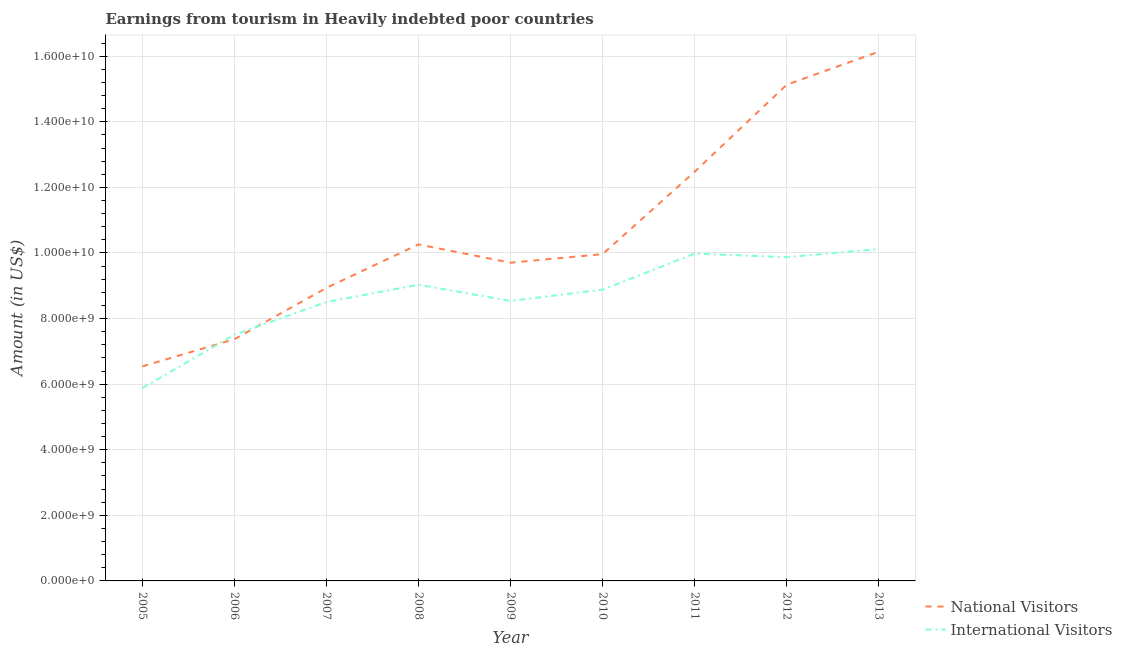Does the line corresponding to amount earned from international visitors intersect with the line corresponding to amount earned from national visitors?
Provide a succinct answer. Yes. What is the amount earned from international visitors in 2008?
Give a very brief answer. 9.03e+09. Across all years, what is the maximum amount earned from national visitors?
Your response must be concise. 1.61e+1. Across all years, what is the minimum amount earned from national visitors?
Keep it short and to the point. 6.54e+09. In which year was the amount earned from national visitors maximum?
Provide a succinct answer. 2013. In which year was the amount earned from national visitors minimum?
Provide a succinct answer. 2005. What is the total amount earned from national visitors in the graph?
Give a very brief answer. 9.65e+1. What is the difference between the amount earned from national visitors in 2007 and that in 2008?
Give a very brief answer. -1.33e+09. What is the difference between the amount earned from international visitors in 2012 and the amount earned from national visitors in 2007?
Keep it short and to the point. 9.35e+08. What is the average amount earned from national visitors per year?
Your answer should be compact. 1.07e+1. In the year 2007, what is the difference between the amount earned from international visitors and amount earned from national visitors?
Your answer should be very brief. -4.31e+08. What is the ratio of the amount earned from national visitors in 2005 to that in 2011?
Make the answer very short. 0.52. What is the difference between the highest and the second highest amount earned from national visitors?
Give a very brief answer. 1.01e+09. What is the difference between the highest and the lowest amount earned from national visitors?
Make the answer very short. 9.60e+09. Is the sum of the amount earned from national visitors in 2012 and 2013 greater than the maximum amount earned from international visitors across all years?
Make the answer very short. Yes. Is the amount earned from international visitors strictly less than the amount earned from national visitors over the years?
Your response must be concise. No. How many lines are there?
Provide a short and direct response. 2. Does the graph contain any zero values?
Offer a very short reply. No. Does the graph contain grids?
Offer a very short reply. Yes. Where does the legend appear in the graph?
Provide a short and direct response. Bottom right. What is the title of the graph?
Keep it short and to the point. Earnings from tourism in Heavily indebted poor countries. What is the label or title of the X-axis?
Keep it short and to the point. Year. What is the Amount (in US$) in National Visitors in 2005?
Give a very brief answer. 6.54e+09. What is the Amount (in US$) of International Visitors in 2005?
Offer a terse response. 5.88e+09. What is the Amount (in US$) in National Visitors in 2006?
Offer a terse response. 7.37e+09. What is the Amount (in US$) in International Visitors in 2006?
Your response must be concise. 7.51e+09. What is the Amount (in US$) of National Visitors in 2007?
Offer a very short reply. 8.94e+09. What is the Amount (in US$) of International Visitors in 2007?
Your response must be concise. 8.50e+09. What is the Amount (in US$) in National Visitors in 2008?
Provide a succinct answer. 1.03e+1. What is the Amount (in US$) of International Visitors in 2008?
Offer a very short reply. 9.03e+09. What is the Amount (in US$) of National Visitors in 2009?
Offer a terse response. 9.70e+09. What is the Amount (in US$) of International Visitors in 2009?
Ensure brevity in your answer.  8.54e+09. What is the Amount (in US$) in National Visitors in 2010?
Your answer should be very brief. 9.96e+09. What is the Amount (in US$) of International Visitors in 2010?
Your answer should be very brief. 8.88e+09. What is the Amount (in US$) in National Visitors in 2011?
Offer a very short reply. 1.25e+1. What is the Amount (in US$) of International Visitors in 2011?
Provide a succinct answer. 9.98e+09. What is the Amount (in US$) of National Visitors in 2012?
Give a very brief answer. 1.51e+1. What is the Amount (in US$) of International Visitors in 2012?
Ensure brevity in your answer.  9.87e+09. What is the Amount (in US$) of National Visitors in 2013?
Your response must be concise. 1.61e+1. What is the Amount (in US$) of International Visitors in 2013?
Your answer should be compact. 1.01e+1. Across all years, what is the maximum Amount (in US$) in National Visitors?
Your answer should be compact. 1.61e+1. Across all years, what is the maximum Amount (in US$) in International Visitors?
Give a very brief answer. 1.01e+1. Across all years, what is the minimum Amount (in US$) in National Visitors?
Offer a very short reply. 6.54e+09. Across all years, what is the minimum Amount (in US$) of International Visitors?
Give a very brief answer. 5.88e+09. What is the total Amount (in US$) of National Visitors in the graph?
Provide a short and direct response. 9.65e+1. What is the total Amount (in US$) in International Visitors in the graph?
Provide a short and direct response. 7.83e+1. What is the difference between the Amount (in US$) of National Visitors in 2005 and that in 2006?
Your answer should be compact. -8.28e+08. What is the difference between the Amount (in US$) of International Visitors in 2005 and that in 2006?
Provide a succinct answer. -1.63e+09. What is the difference between the Amount (in US$) of National Visitors in 2005 and that in 2007?
Provide a short and direct response. -2.39e+09. What is the difference between the Amount (in US$) of International Visitors in 2005 and that in 2007?
Ensure brevity in your answer.  -2.62e+09. What is the difference between the Amount (in US$) of National Visitors in 2005 and that in 2008?
Ensure brevity in your answer.  -3.72e+09. What is the difference between the Amount (in US$) of International Visitors in 2005 and that in 2008?
Your answer should be compact. -3.15e+09. What is the difference between the Amount (in US$) of National Visitors in 2005 and that in 2009?
Give a very brief answer. -3.16e+09. What is the difference between the Amount (in US$) in International Visitors in 2005 and that in 2009?
Make the answer very short. -2.66e+09. What is the difference between the Amount (in US$) of National Visitors in 2005 and that in 2010?
Make the answer very short. -3.42e+09. What is the difference between the Amount (in US$) in International Visitors in 2005 and that in 2010?
Your response must be concise. -3.00e+09. What is the difference between the Amount (in US$) of National Visitors in 2005 and that in 2011?
Provide a succinct answer. -5.93e+09. What is the difference between the Amount (in US$) in International Visitors in 2005 and that in 2011?
Your response must be concise. -4.10e+09. What is the difference between the Amount (in US$) of National Visitors in 2005 and that in 2012?
Offer a terse response. -8.59e+09. What is the difference between the Amount (in US$) of International Visitors in 2005 and that in 2012?
Provide a short and direct response. -3.99e+09. What is the difference between the Amount (in US$) in National Visitors in 2005 and that in 2013?
Offer a very short reply. -9.60e+09. What is the difference between the Amount (in US$) of International Visitors in 2005 and that in 2013?
Your answer should be compact. -4.24e+09. What is the difference between the Amount (in US$) in National Visitors in 2006 and that in 2007?
Offer a very short reply. -1.57e+09. What is the difference between the Amount (in US$) of International Visitors in 2006 and that in 2007?
Your answer should be very brief. -9.96e+08. What is the difference between the Amount (in US$) in National Visitors in 2006 and that in 2008?
Give a very brief answer. -2.89e+09. What is the difference between the Amount (in US$) of International Visitors in 2006 and that in 2008?
Ensure brevity in your answer.  -1.52e+09. What is the difference between the Amount (in US$) in National Visitors in 2006 and that in 2009?
Make the answer very short. -2.33e+09. What is the difference between the Amount (in US$) in International Visitors in 2006 and that in 2009?
Provide a short and direct response. -1.03e+09. What is the difference between the Amount (in US$) of National Visitors in 2006 and that in 2010?
Your response must be concise. -2.59e+09. What is the difference between the Amount (in US$) in International Visitors in 2006 and that in 2010?
Make the answer very short. -1.37e+09. What is the difference between the Amount (in US$) in National Visitors in 2006 and that in 2011?
Your response must be concise. -5.11e+09. What is the difference between the Amount (in US$) of International Visitors in 2006 and that in 2011?
Offer a terse response. -2.47e+09. What is the difference between the Amount (in US$) in National Visitors in 2006 and that in 2012?
Offer a very short reply. -7.76e+09. What is the difference between the Amount (in US$) of International Visitors in 2006 and that in 2012?
Your answer should be very brief. -2.36e+09. What is the difference between the Amount (in US$) in National Visitors in 2006 and that in 2013?
Offer a terse response. -8.77e+09. What is the difference between the Amount (in US$) in International Visitors in 2006 and that in 2013?
Keep it short and to the point. -2.61e+09. What is the difference between the Amount (in US$) of National Visitors in 2007 and that in 2008?
Give a very brief answer. -1.33e+09. What is the difference between the Amount (in US$) in International Visitors in 2007 and that in 2008?
Offer a very short reply. -5.27e+08. What is the difference between the Amount (in US$) in National Visitors in 2007 and that in 2009?
Give a very brief answer. -7.68e+08. What is the difference between the Amount (in US$) in International Visitors in 2007 and that in 2009?
Your response must be concise. -3.33e+07. What is the difference between the Amount (in US$) of National Visitors in 2007 and that in 2010?
Your response must be concise. -1.03e+09. What is the difference between the Amount (in US$) of International Visitors in 2007 and that in 2010?
Provide a succinct answer. -3.77e+08. What is the difference between the Amount (in US$) of National Visitors in 2007 and that in 2011?
Provide a short and direct response. -3.54e+09. What is the difference between the Amount (in US$) in International Visitors in 2007 and that in 2011?
Give a very brief answer. -1.48e+09. What is the difference between the Amount (in US$) in National Visitors in 2007 and that in 2012?
Provide a succinct answer. -6.19e+09. What is the difference between the Amount (in US$) in International Visitors in 2007 and that in 2012?
Offer a very short reply. -1.37e+09. What is the difference between the Amount (in US$) of National Visitors in 2007 and that in 2013?
Provide a short and direct response. -7.20e+09. What is the difference between the Amount (in US$) of International Visitors in 2007 and that in 2013?
Your answer should be very brief. -1.62e+09. What is the difference between the Amount (in US$) in National Visitors in 2008 and that in 2009?
Provide a short and direct response. 5.58e+08. What is the difference between the Amount (in US$) in International Visitors in 2008 and that in 2009?
Give a very brief answer. 4.94e+08. What is the difference between the Amount (in US$) of National Visitors in 2008 and that in 2010?
Your answer should be compact. 2.97e+08. What is the difference between the Amount (in US$) of International Visitors in 2008 and that in 2010?
Your response must be concise. 1.50e+08. What is the difference between the Amount (in US$) of National Visitors in 2008 and that in 2011?
Give a very brief answer. -2.22e+09. What is the difference between the Amount (in US$) in International Visitors in 2008 and that in 2011?
Offer a very short reply. -9.49e+08. What is the difference between the Amount (in US$) in National Visitors in 2008 and that in 2012?
Provide a short and direct response. -4.87e+09. What is the difference between the Amount (in US$) in International Visitors in 2008 and that in 2012?
Your answer should be compact. -8.39e+08. What is the difference between the Amount (in US$) of National Visitors in 2008 and that in 2013?
Your response must be concise. -5.88e+09. What is the difference between the Amount (in US$) in International Visitors in 2008 and that in 2013?
Provide a short and direct response. -1.09e+09. What is the difference between the Amount (in US$) of National Visitors in 2009 and that in 2010?
Offer a terse response. -2.61e+08. What is the difference between the Amount (in US$) of International Visitors in 2009 and that in 2010?
Ensure brevity in your answer.  -3.44e+08. What is the difference between the Amount (in US$) in National Visitors in 2009 and that in 2011?
Give a very brief answer. -2.77e+09. What is the difference between the Amount (in US$) of International Visitors in 2009 and that in 2011?
Offer a very short reply. -1.44e+09. What is the difference between the Amount (in US$) of National Visitors in 2009 and that in 2012?
Offer a very short reply. -5.43e+09. What is the difference between the Amount (in US$) of International Visitors in 2009 and that in 2012?
Offer a very short reply. -1.33e+09. What is the difference between the Amount (in US$) in National Visitors in 2009 and that in 2013?
Give a very brief answer. -6.43e+09. What is the difference between the Amount (in US$) of International Visitors in 2009 and that in 2013?
Provide a short and direct response. -1.58e+09. What is the difference between the Amount (in US$) in National Visitors in 2010 and that in 2011?
Offer a very short reply. -2.51e+09. What is the difference between the Amount (in US$) in International Visitors in 2010 and that in 2011?
Your answer should be compact. -1.10e+09. What is the difference between the Amount (in US$) in National Visitors in 2010 and that in 2012?
Offer a terse response. -5.17e+09. What is the difference between the Amount (in US$) of International Visitors in 2010 and that in 2012?
Your response must be concise. -9.89e+08. What is the difference between the Amount (in US$) of National Visitors in 2010 and that in 2013?
Ensure brevity in your answer.  -6.17e+09. What is the difference between the Amount (in US$) of International Visitors in 2010 and that in 2013?
Your response must be concise. -1.24e+09. What is the difference between the Amount (in US$) in National Visitors in 2011 and that in 2012?
Provide a succinct answer. -2.65e+09. What is the difference between the Amount (in US$) in International Visitors in 2011 and that in 2012?
Make the answer very short. 1.10e+08. What is the difference between the Amount (in US$) in National Visitors in 2011 and that in 2013?
Offer a very short reply. -3.66e+09. What is the difference between the Amount (in US$) in International Visitors in 2011 and that in 2013?
Offer a terse response. -1.41e+08. What is the difference between the Amount (in US$) of National Visitors in 2012 and that in 2013?
Give a very brief answer. -1.01e+09. What is the difference between the Amount (in US$) of International Visitors in 2012 and that in 2013?
Your answer should be compact. -2.51e+08. What is the difference between the Amount (in US$) of National Visitors in 2005 and the Amount (in US$) of International Visitors in 2006?
Give a very brief answer. -9.66e+08. What is the difference between the Amount (in US$) in National Visitors in 2005 and the Amount (in US$) in International Visitors in 2007?
Your answer should be compact. -1.96e+09. What is the difference between the Amount (in US$) of National Visitors in 2005 and the Amount (in US$) of International Visitors in 2008?
Your answer should be compact. -2.49e+09. What is the difference between the Amount (in US$) of National Visitors in 2005 and the Amount (in US$) of International Visitors in 2009?
Your answer should be very brief. -2.00e+09. What is the difference between the Amount (in US$) of National Visitors in 2005 and the Amount (in US$) of International Visitors in 2010?
Offer a terse response. -2.34e+09. What is the difference between the Amount (in US$) of National Visitors in 2005 and the Amount (in US$) of International Visitors in 2011?
Keep it short and to the point. -3.44e+09. What is the difference between the Amount (in US$) in National Visitors in 2005 and the Amount (in US$) in International Visitors in 2012?
Your answer should be very brief. -3.33e+09. What is the difference between the Amount (in US$) in National Visitors in 2005 and the Amount (in US$) in International Visitors in 2013?
Offer a terse response. -3.58e+09. What is the difference between the Amount (in US$) in National Visitors in 2006 and the Amount (in US$) in International Visitors in 2007?
Your answer should be very brief. -1.13e+09. What is the difference between the Amount (in US$) in National Visitors in 2006 and the Amount (in US$) in International Visitors in 2008?
Provide a succinct answer. -1.66e+09. What is the difference between the Amount (in US$) of National Visitors in 2006 and the Amount (in US$) of International Visitors in 2009?
Make the answer very short. -1.17e+09. What is the difference between the Amount (in US$) in National Visitors in 2006 and the Amount (in US$) in International Visitors in 2010?
Your answer should be compact. -1.51e+09. What is the difference between the Amount (in US$) of National Visitors in 2006 and the Amount (in US$) of International Visitors in 2011?
Make the answer very short. -2.61e+09. What is the difference between the Amount (in US$) in National Visitors in 2006 and the Amount (in US$) in International Visitors in 2012?
Provide a succinct answer. -2.50e+09. What is the difference between the Amount (in US$) of National Visitors in 2006 and the Amount (in US$) of International Visitors in 2013?
Offer a terse response. -2.75e+09. What is the difference between the Amount (in US$) of National Visitors in 2007 and the Amount (in US$) of International Visitors in 2008?
Your answer should be compact. -9.58e+07. What is the difference between the Amount (in US$) in National Visitors in 2007 and the Amount (in US$) in International Visitors in 2009?
Keep it short and to the point. 3.98e+08. What is the difference between the Amount (in US$) of National Visitors in 2007 and the Amount (in US$) of International Visitors in 2010?
Offer a very short reply. 5.44e+07. What is the difference between the Amount (in US$) of National Visitors in 2007 and the Amount (in US$) of International Visitors in 2011?
Your answer should be very brief. -1.04e+09. What is the difference between the Amount (in US$) in National Visitors in 2007 and the Amount (in US$) in International Visitors in 2012?
Ensure brevity in your answer.  -9.35e+08. What is the difference between the Amount (in US$) of National Visitors in 2007 and the Amount (in US$) of International Visitors in 2013?
Ensure brevity in your answer.  -1.19e+09. What is the difference between the Amount (in US$) in National Visitors in 2008 and the Amount (in US$) in International Visitors in 2009?
Your response must be concise. 1.72e+09. What is the difference between the Amount (in US$) in National Visitors in 2008 and the Amount (in US$) in International Visitors in 2010?
Ensure brevity in your answer.  1.38e+09. What is the difference between the Amount (in US$) in National Visitors in 2008 and the Amount (in US$) in International Visitors in 2011?
Offer a terse response. 2.81e+08. What is the difference between the Amount (in US$) in National Visitors in 2008 and the Amount (in US$) in International Visitors in 2012?
Your answer should be compact. 3.91e+08. What is the difference between the Amount (in US$) in National Visitors in 2008 and the Amount (in US$) in International Visitors in 2013?
Your answer should be compact. 1.40e+08. What is the difference between the Amount (in US$) of National Visitors in 2009 and the Amount (in US$) of International Visitors in 2010?
Provide a succinct answer. 8.22e+08. What is the difference between the Amount (in US$) of National Visitors in 2009 and the Amount (in US$) of International Visitors in 2011?
Keep it short and to the point. -2.77e+08. What is the difference between the Amount (in US$) of National Visitors in 2009 and the Amount (in US$) of International Visitors in 2012?
Your answer should be very brief. -1.67e+08. What is the difference between the Amount (in US$) of National Visitors in 2009 and the Amount (in US$) of International Visitors in 2013?
Ensure brevity in your answer.  -4.18e+08. What is the difference between the Amount (in US$) in National Visitors in 2010 and the Amount (in US$) in International Visitors in 2011?
Your answer should be compact. -1.64e+07. What is the difference between the Amount (in US$) in National Visitors in 2010 and the Amount (in US$) in International Visitors in 2012?
Ensure brevity in your answer.  9.36e+07. What is the difference between the Amount (in US$) in National Visitors in 2010 and the Amount (in US$) in International Visitors in 2013?
Your response must be concise. -1.57e+08. What is the difference between the Amount (in US$) of National Visitors in 2011 and the Amount (in US$) of International Visitors in 2012?
Keep it short and to the point. 2.61e+09. What is the difference between the Amount (in US$) of National Visitors in 2011 and the Amount (in US$) of International Visitors in 2013?
Ensure brevity in your answer.  2.36e+09. What is the difference between the Amount (in US$) in National Visitors in 2012 and the Amount (in US$) in International Visitors in 2013?
Your answer should be very brief. 5.01e+09. What is the average Amount (in US$) of National Visitors per year?
Offer a very short reply. 1.07e+1. What is the average Amount (in US$) in International Visitors per year?
Your answer should be compact. 8.70e+09. In the year 2005, what is the difference between the Amount (in US$) of National Visitors and Amount (in US$) of International Visitors?
Keep it short and to the point. 6.62e+08. In the year 2006, what is the difference between the Amount (in US$) in National Visitors and Amount (in US$) in International Visitors?
Provide a succinct answer. -1.37e+08. In the year 2007, what is the difference between the Amount (in US$) of National Visitors and Amount (in US$) of International Visitors?
Your response must be concise. 4.31e+08. In the year 2008, what is the difference between the Amount (in US$) of National Visitors and Amount (in US$) of International Visitors?
Ensure brevity in your answer.  1.23e+09. In the year 2009, what is the difference between the Amount (in US$) in National Visitors and Amount (in US$) in International Visitors?
Offer a very short reply. 1.17e+09. In the year 2010, what is the difference between the Amount (in US$) in National Visitors and Amount (in US$) in International Visitors?
Offer a terse response. 1.08e+09. In the year 2011, what is the difference between the Amount (in US$) in National Visitors and Amount (in US$) in International Visitors?
Provide a succinct answer. 2.50e+09. In the year 2012, what is the difference between the Amount (in US$) in National Visitors and Amount (in US$) in International Visitors?
Your response must be concise. 5.26e+09. In the year 2013, what is the difference between the Amount (in US$) in National Visitors and Amount (in US$) in International Visitors?
Ensure brevity in your answer.  6.02e+09. What is the ratio of the Amount (in US$) in National Visitors in 2005 to that in 2006?
Offer a terse response. 0.89. What is the ratio of the Amount (in US$) in International Visitors in 2005 to that in 2006?
Ensure brevity in your answer.  0.78. What is the ratio of the Amount (in US$) of National Visitors in 2005 to that in 2007?
Make the answer very short. 0.73. What is the ratio of the Amount (in US$) in International Visitors in 2005 to that in 2007?
Offer a very short reply. 0.69. What is the ratio of the Amount (in US$) in National Visitors in 2005 to that in 2008?
Offer a terse response. 0.64. What is the ratio of the Amount (in US$) in International Visitors in 2005 to that in 2008?
Give a very brief answer. 0.65. What is the ratio of the Amount (in US$) in National Visitors in 2005 to that in 2009?
Give a very brief answer. 0.67. What is the ratio of the Amount (in US$) in International Visitors in 2005 to that in 2009?
Your answer should be compact. 0.69. What is the ratio of the Amount (in US$) in National Visitors in 2005 to that in 2010?
Your answer should be very brief. 0.66. What is the ratio of the Amount (in US$) in International Visitors in 2005 to that in 2010?
Ensure brevity in your answer.  0.66. What is the ratio of the Amount (in US$) of National Visitors in 2005 to that in 2011?
Give a very brief answer. 0.52. What is the ratio of the Amount (in US$) of International Visitors in 2005 to that in 2011?
Give a very brief answer. 0.59. What is the ratio of the Amount (in US$) of National Visitors in 2005 to that in 2012?
Ensure brevity in your answer.  0.43. What is the ratio of the Amount (in US$) in International Visitors in 2005 to that in 2012?
Make the answer very short. 0.6. What is the ratio of the Amount (in US$) of National Visitors in 2005 to that in 2013?
Provide a short and direct response. 0.41. What is the ratio of the Amount (in US$) of International Visitors in 2005 to that in 2013?
Your answer should be compact. 0.58. What is the ratio of the Amount (in US$) of National Visitors in 2006 to that in 2007?
Make the answer very short. 0.82. What is the ratio of the Amount (in US$) in International Visitors in 2006 to that in 2007?
Your response must be concise. 0.88. What is the ratio of the Amount (in US$) in National Visitors in 2006 to that in 2008?
Give a very brief answer. 0.72. What is the ratio of the Amount (in US$) in International Visitors in 2006 to that in 2008?
Provide a succinct answer. 0.83. What is the ratio of the Amount (in US$) in National Visitors in 2006 to that in 2009?
Give a very brief answer. 0.76. What is the ratio of the Amount (in US$) of International Visitors in 2006 to that in 2009?
Your answer should be compact. 0.88. What is the ratio of the Amount (in US$) of National Visitors in 2006 to that in 2010?
Keep it short and to the point. 0.74. What is the ratio of the Amount (in US$) of International Visitors in 2006 to that in 2010?
Keep it short and to the point. 0.85. What is the ratio of the Amount (in US$) in National Visitors in 2006 to that in 2011?
Give a very brief answer. 0.59. What is the ratio of the Amount (in US$) of International Visitors in 2006 to that in 2011?
Keep it short and to the point. 0.75. What is the ratio of the Amount (in US$) of National Visitors in 2006 to that in 2012?
Provide a short and direct response. 0.49. What is the ratio of the Amount (in US$) of International Visitors in 2006 to that in 2012?
Keep it short and to the point. 0.76. What is the ratio of the Amount (in US$) of National Visitors in 2006 to that in 2013?
Your answer should be compact. 0.46. What is the ratio of the Amount (in US$) of International Visitors in 2006 to that in 2013?
Offer a very short reply. 0.74. What is the ratio of the Amount (in US$) in National Visitors in 2007 to that in 2008?
Your response must be concise. 0.87. What is the ratio of the Amount (in US$) in International Visitors in 2007 to that in 2008?
Provide a short and direct response. 0.94. What is the ratio of the Amount (in US$) of National Visitors in 2007 to that in 2009?
Provide a succinct answer. 0.92. What is the ratio of the Amount (in US$) in International Visitors in 2007 to that in 2009?
Provide a short and direct response. 1. What is the ratio of the Amount (in US$) in National Visitors in 2007 to that in 2010?
Provide a succinct answer. 0.9. What is the ratio of the Amount (in US$) in International Visitors in 2007 to that in 2010?
Make the answer very short. 0.96. What is the ratio of the Amount (in US$) of National Visitors in 2007 to that in 2011?
Offer a terse response. 0.72. What is the ratio of the Amount (in US$) in International Visitors in 2007 to that in 2011?
Offer a terse response. 0.85. What is the ratio of the Amount (in US$) of National Visitors in 2007 to that in 2012?
Make the answer very short. 0.59. What is the ratio of the Amount (in US$) in International Visitors in 2007 to that in 2012?
Your answer should be very brief. 0.86. What is the ratio of the Amount (in US$) in National Visitors in 2007 to that in 2013?
Provide a short and direct response. 0.55. What is the ratio of the Amount (in US$) in International Visitors in 2007 to that in 2013?
Your response must be concise. 0.84. What is the ratio of the Amount (in US$) of National Visitors in 2008 to that in 2009?
Offer a terse response. 1.06. What is the ratio of the Amount (in US$) of International Visitors in 2008 to that in 2009?
Offer a very short reply. 1.06. What is the ratio of the Amount (in US$) in National Visitors in 2008 to that in 2010?
Keep it short and to the point. 1.03. What is the ratio of the Amount (in US$) of International Visitors in 2008 to that in 2010?
Your answer should be compact. 1.02. What is the ratio of the Amount (in US$) in National Visitors in 2008 to that in 2011?
Give a very brief answer. 0.82. What is the ratio of the Amount (in US$) in International Visitors in 2008 to that in 2011?
Ensure brevity in your answer.  0.9. What is the ratio of the Amount (in US$) in National Visitors in 2008 to that in 2012?
Provide a succinct answer. 0.68. What is the ratio of the Amount (in US$) in International Visitors in 2008 to that in 2012?
Offer a terse response. 0.92. What is the ratio of the Amount (in US$) in National Visitors in 2008 to that in 2013?
Provide a short and direct response. 0.64. What is the ratio of the Amount (in US$) of International Visitors in 2008 to that in 2013?
Ensure brevity in your answer.  0.89. What is the ratio of the Amount (in US$) of National Visitors in 2009 to that in 2010?
Offer a very short reply. 0.97. What is the ratio of the Amount (in US$) in International Visitors in 2009 to that in 2010?
Provide a succinct answer. 0.96. What is the ratio of the Amount (in US$) of National Visitors in 2009 to that in 2011?
Provide a short and direct response. 0.78. What is the ratio of the Amount (in US$) of International Visitors in 2009 to that in 2011?
Ensure brevity in your answer.  0.86. What is the ratio of the Amount (in US$) of National Visitors in 2009 to that in 2012?
Your answer should be compact. 0.64. What is the ratio of the Amount (in US$) in International Visitors in 2009 to that in 2012?
Offer a terse response. 0.86. What is the ratio of the Amount (in US$) of National Visitors in 2009 to that in 2013?
Keep it short and to the point. 0.6. What is the ratio of the Amount (in US$) in International Visitors in 2009 to that in 2013?
Ensure brevity in your answer.  0.84. What is the ratio of the Amount (in US$) in National Visitors in 2010 to that in 2011?
Make the answer very short. 0.8. What is the ratio of the Amount (in US$) of International Visitors in 2010 to that in 2011?
Your response must be concise. 0.89. What is the ratio of the Amount (in US$) in National Visitors in 2010 to that in 2012?
Provide a short and direct response. 0.66. What is the ratio of the Amount (in US$) in International Visitors in 2010 to that in 2012?
Keep it short and to the point. 0.9. What is the ratio of the Amount (in US$) in National Visitors in 2010 to that in 2013?
Offer a very short reply. 0.62. What is the ratio of the Amount (in US$) in International Visitors in 2010 to that in 2013?
Give a very brief answer. 0.88. What is the ratio of the Amount (in US$) of National Visitors in 2011 to that in 2012?
Provide a succinct answer. 0.82. What is the ratio of the Amount (in US$) of International Visitors in 2011 to that in 2012?
Keep it short and to the point. 1.01. What is the ratio of the Amount (in US$) in National Visitors in 2011 to that in 2013?
Make the answer very short. 0.77. What is the ratio of the Amount (in US$) of International Visitors in 2011 to that in 2013?
Provide a succinct answer. 0.99. What is the ratio of the Amount (in US$) in National Visitors in 2012 to that in 2013?
Give a very brief answer. 0.94. What is the ratio of the Amount (in US$) of International Visitors in 2012 to that in 2013?
Your response must be concise. 0.98. What is the difference between the highest and the second highest Amount (in US$) of National Visitors?
Keep it short and to the point. 1.01e+09. What is the difference between the highest and the second highest Amount (in US$) in International Visitors?
Offer a terse response. 1.41e+08. What is the difference between the highest and the lowest Amount (in US$) of National Visitors?
Keep it short and to the point. 9.60e+09. What is the difference between the highest and the lowest Amount (in US$) of International Visitors?
Your answer should be very brief. 4.24e+09. 